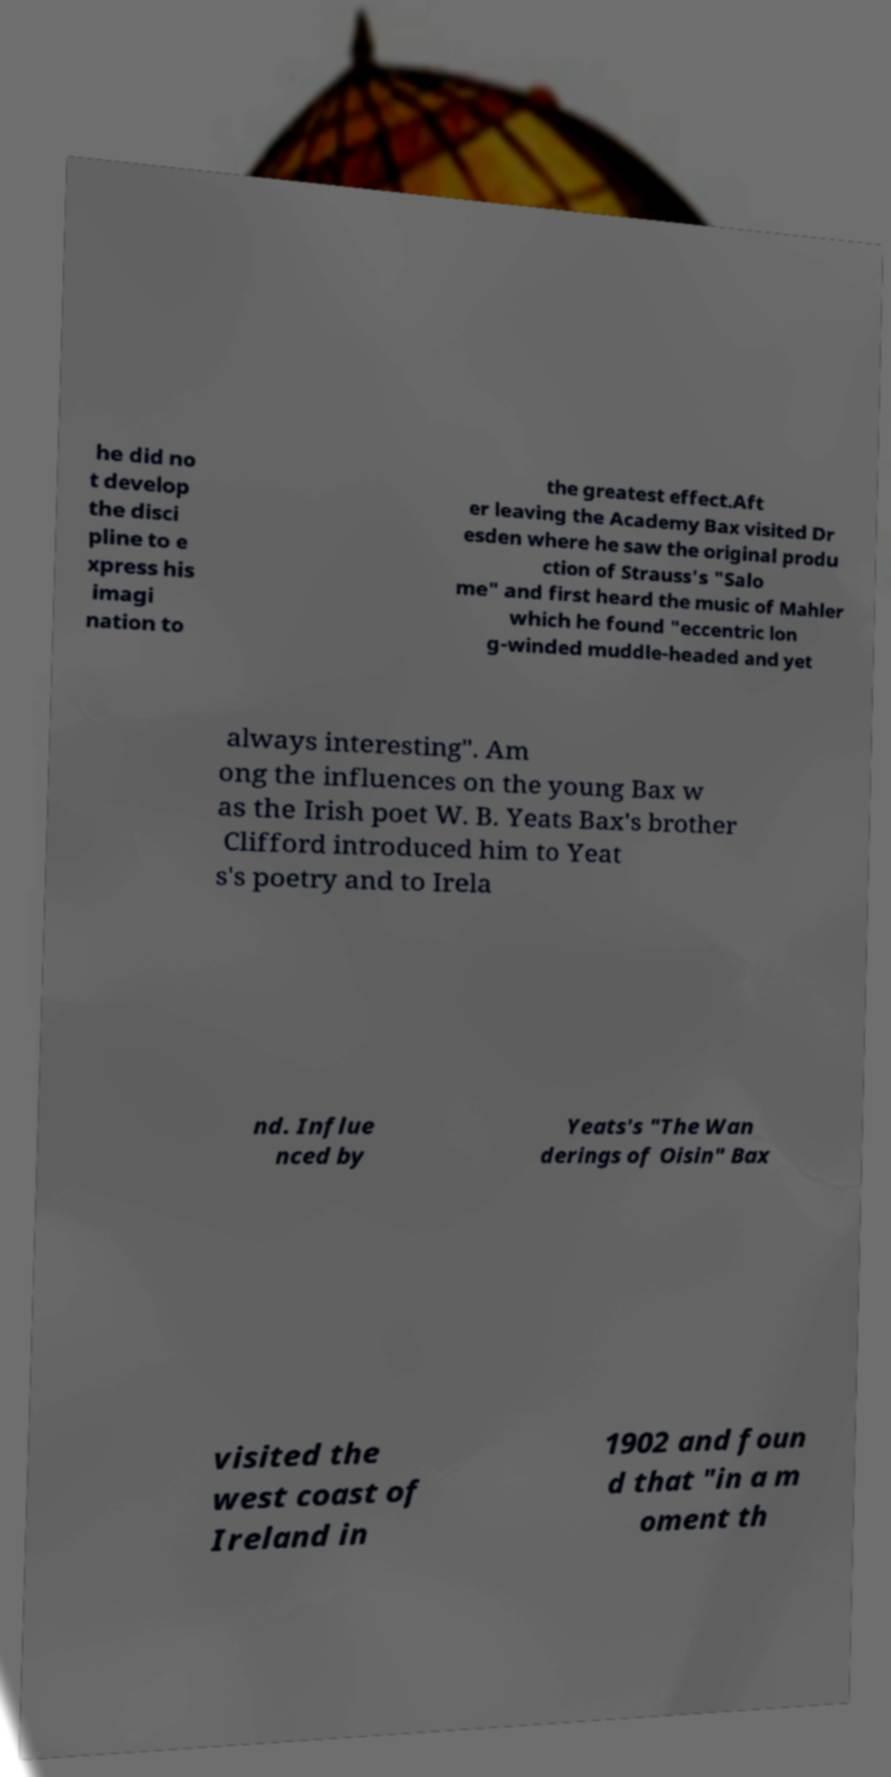Please identify and transcribe the text found in this image. he did no t develop the disci pline to e xpress his imagi nation to the greatest effect.Aft er leaving the Academy Bax visited Dr esden where he saw the original produ ction of Strauss's "Salo me" and first heard the music of Mahler which he found "eccentric lon g-winded muddle-headed and yet always interesting". Am ong the influences on the young Bax w as the Irish poet W. B. Yeats Bax's brother Clifford introduced him to Yeat s's poetry and to Irela nd. Influe nced by Yeats's "The Wan derings of Oisin" Bax visited the west coast of Ireland in 1902 and foun d that "in a m oment th 